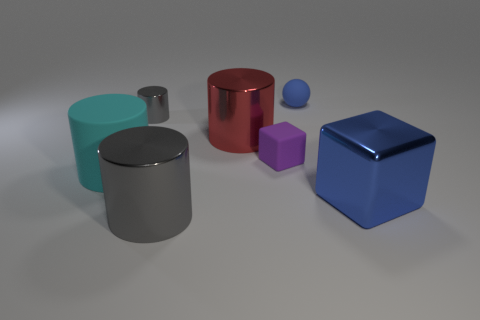What is the color of the rubber thing that is both behind the large cyan rubber cylinder and to the left of the tiny blue sphere?
Offer a terse response. Purple. Are there fewer gray cylinders that are in front of the large metallic cube than objects that are in front of the large red shiny cylinder?
Provide a succinct answer. Yes. What number of blue metallic objects are the same shape as the big gray object?
Your answer should be very brief. 0. There is a cube that is the same material as the large cyan cylinder; what size is it?
Give a very brief answer. Small. What color is the metallic cylinder on the right side of the large cylinder that is in front of the big blue metallic cube?
Make the answer very short. Red. Does the purple matte thing have the same shape as the blue object that is in front of the big red metal thing?
Keep it short and to the point. Yes. What number of other matte blocks are the same size as the matte block?
Ensure brevity in your answer.  0. What material is the cyan object that is the same shape as the small gray object?
Provide a short and direct response. Rubber. Do the small rubber object that is on the left side of the tiny blue matte thing and the rubber thing behind the small cylinder have the same color?
Your answer should be compact. No. What shape is the gray metallic thing that is behind the big cube?
Your answer should be compact. Cylinder. 